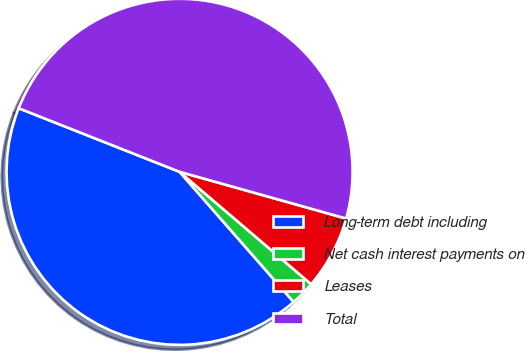Convert chart to OTSL. <chart><loc_0><loc_0><loc_500><loc_500><pie_chart><fcel>Long-term debt including<fcel>Net cash interest payments on<fcel>Leases<fcel>Total<nl><fcel>42.44%<fcel>2.3%<fcel>6.9%<fcel>48.36%<nl></chart> 